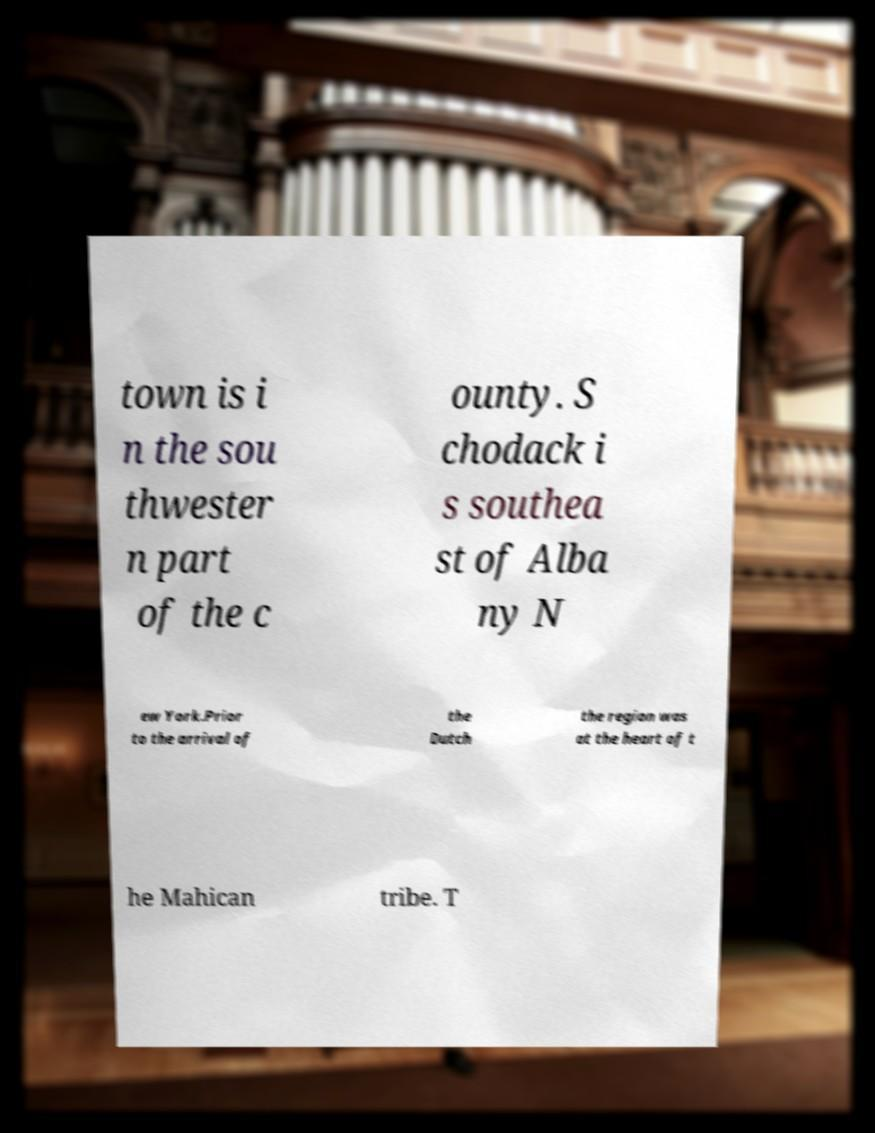Please read and relay the text visible in this image. What does it say? town is i n the sou thwester n part of the c ounty. S chodack i s southea st of Alba ny N ew York.Prior to the arrival of the Dutch the region was at the heart of t he Mahican tribe. T 